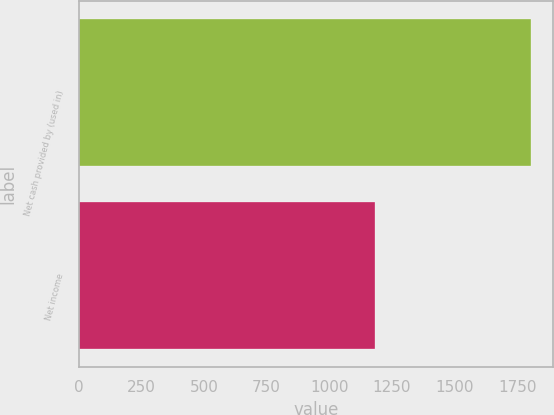Convert chart to OTSL. <chart><loc_0><loc_0><loc_500><loc_500><bar_chart><fcel>Net cash provided by (used in)<fcel>Net income<nl><fcel>1803<fcel>1182<nl></chart> 